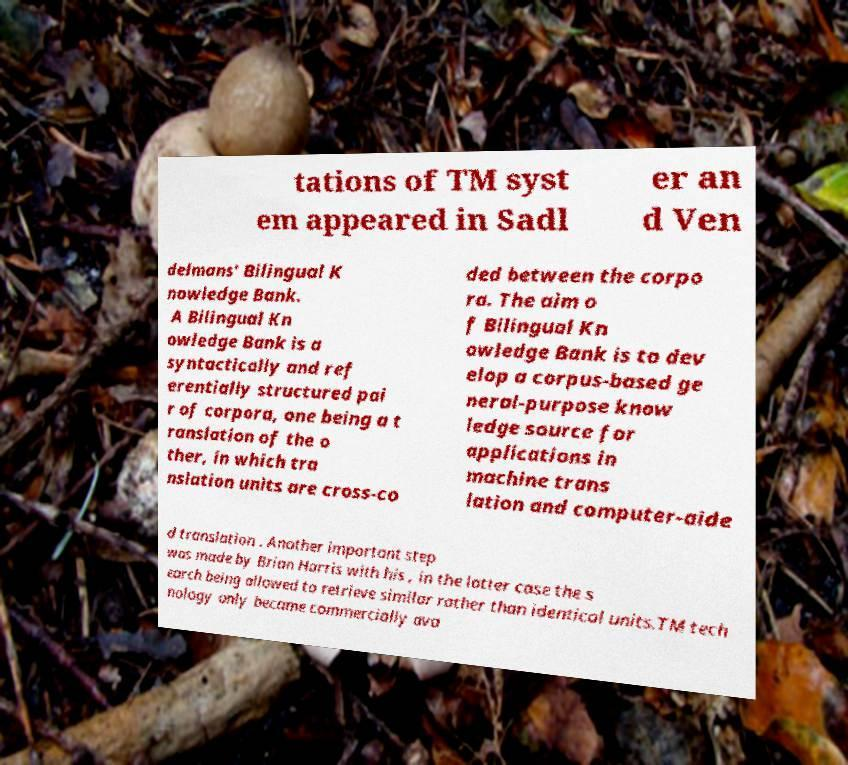Can you read and provide the text displayed in the image?This photo seems to have some interesting text. Can you extract and type it out for me? tations of TM syst em appeared in Sadl er an d Ven delmans' Bilingual K nowledge Bank. A Bilingual Kn owledge Bank is a syntactically and ref erentially structured pai r of corpora, one being a t ranslation of the o ther, in which tra nslation units are cross-co ded between the corpo ra. The aim o f Bilingual Kn owledge Bank is to dev elop a corpus-based ge neral-purpose know ledge source for applications in machine trans lation and computer-aide d translation . Another important step was made by Brian Harris with his , in the latter case the s earch being allowed to retrieve similar rather than identical units.TM tech nology only became commercially ava 